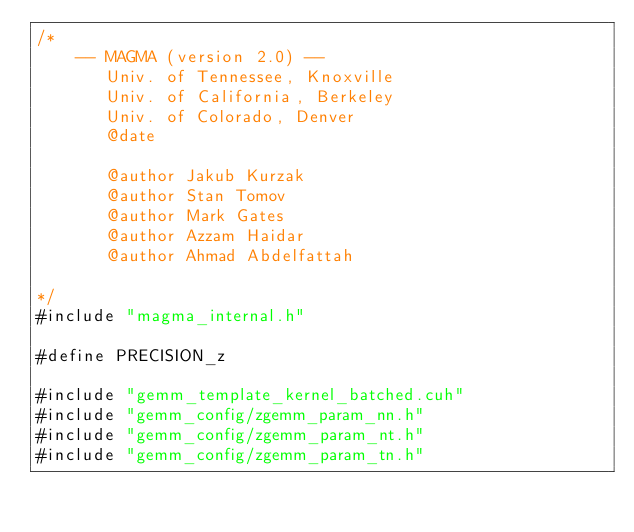<code> <loc_0><loc_0><loc_500><loc_500><_Cuda_>/*
    -- MAGMA (version 2.0) --
       Univ. of Tennessee, Knoxville
       Univ. of California, Berkeley
       Univ. of Colorado, Denver
       @date

       @author Jakub Kurzak
       @author Stan Tomov
       @author Mark Gates
       @author Azzam Haidar
       @author Ahmad Abdelfattah
       
*/
#include "magma_internal.h"

#define PRECISION_z

#include "gemm_template_kernel_batched.cuh"
#include "gemm_config/zgemm_param_nn.h"
#include "gemm_config/zgemm_param_nt.h"
#include "gemm_config/zgemm_param_tn.h"</code> 